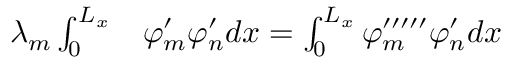<formula> <loc_0><loc_0><loc_500><loc_500>\begin{array} { r l } { \lambda _ { m } \int _ { 0 } ^ { L _ { x } } } & \varphi _ { m } ^ { \prime } \varphi _ { n } ^ { \prime } d x = \int _ { 0 } ^ { L _ { x } } \varphi _ { m } ^ { \prime \prime \prime \prime \prime } \varphi _ { n } ^ { \prime } d x } \end{array}</formula> 